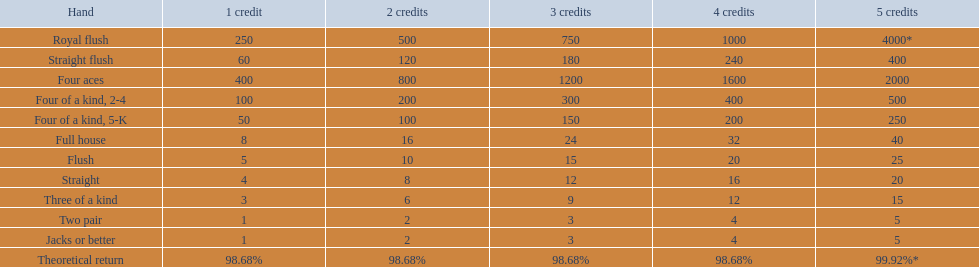At most, what could a person earn for having a full house? 40. 